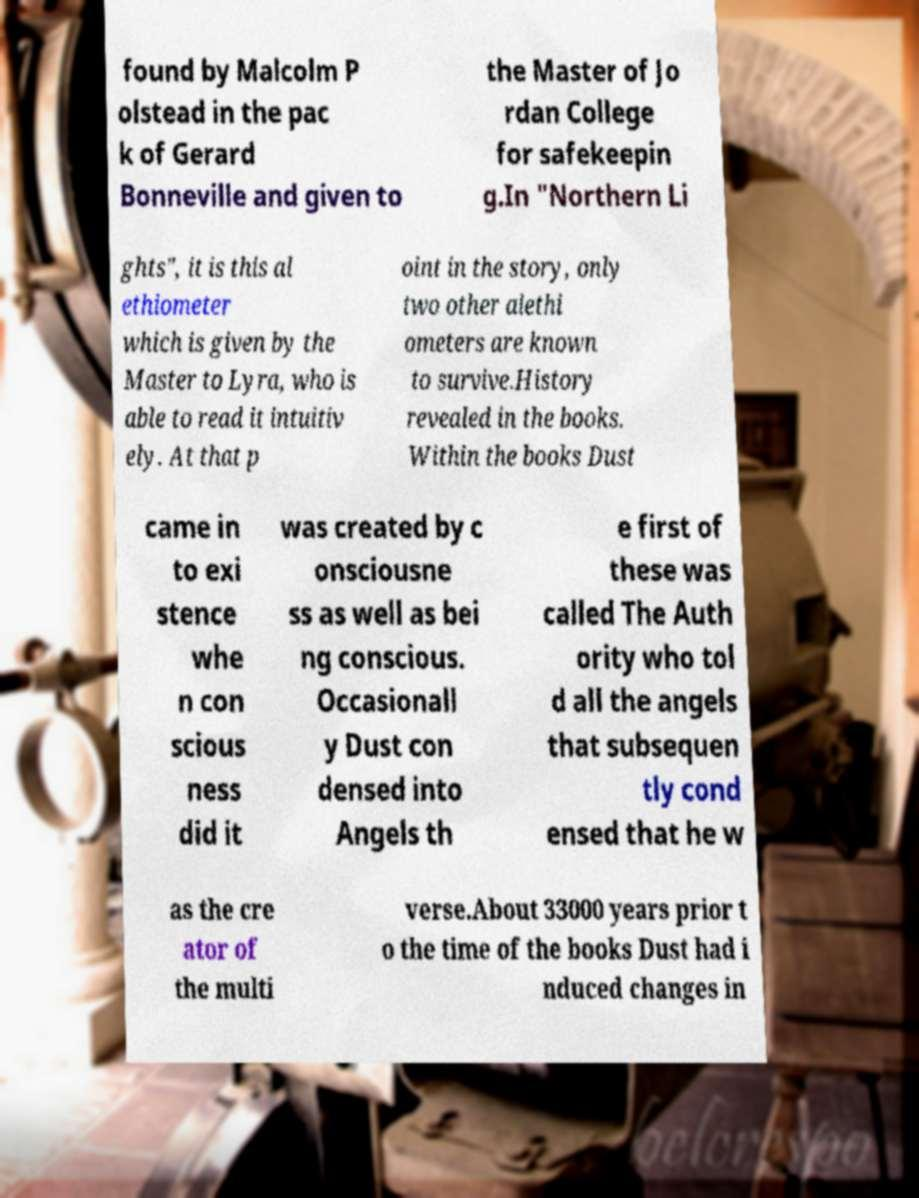For documentation purposes, I need the text within this image transcribed. Could you provide that? found by Malcolm P olstead in the pac k of Gerard Bonneville and given to the Master of Jo rdan College for safekeepin g.In "Northern Li ghts", it is this al ethiometer which is given by the Master to Lyra, who is able to read it intuitiv ely. At that p oint in the story, only two other alethi ometers are known to survive.History revealed in the books. Within the books Dust came in to exi stence whe n con scious ness did it was created by c onsciousne ss as well as bei ng conscious. Occasionall y Dust con densed into Angels th e first of these was called The Auth ority who tol d all the angels that subsequen tly cond ensed that he w as the cre ator of the multi verse.About 33000 years prior t o the time of the books Dust had i nduced changes in 